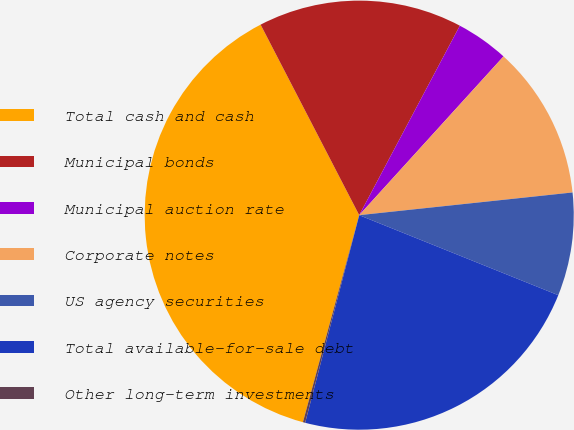Convert chart. <chart><loc_0><loc_0><loc_500><loc_500><pie_chart><fcel>Total cash and cash<fcel>Municipal bonds<fcel>Municipal auction rate<fcel>Corporate notes<fcel>US agency securities<fcel>Total available-for-sale debt<fcel>Other long-term investments<nl><fcel>38.17%<fcel>15.37%<fcel>3.97%<fcel>11.57%<fcel>7.77%<fcel>22.97%<fcel>0.17%<nl></chart> 